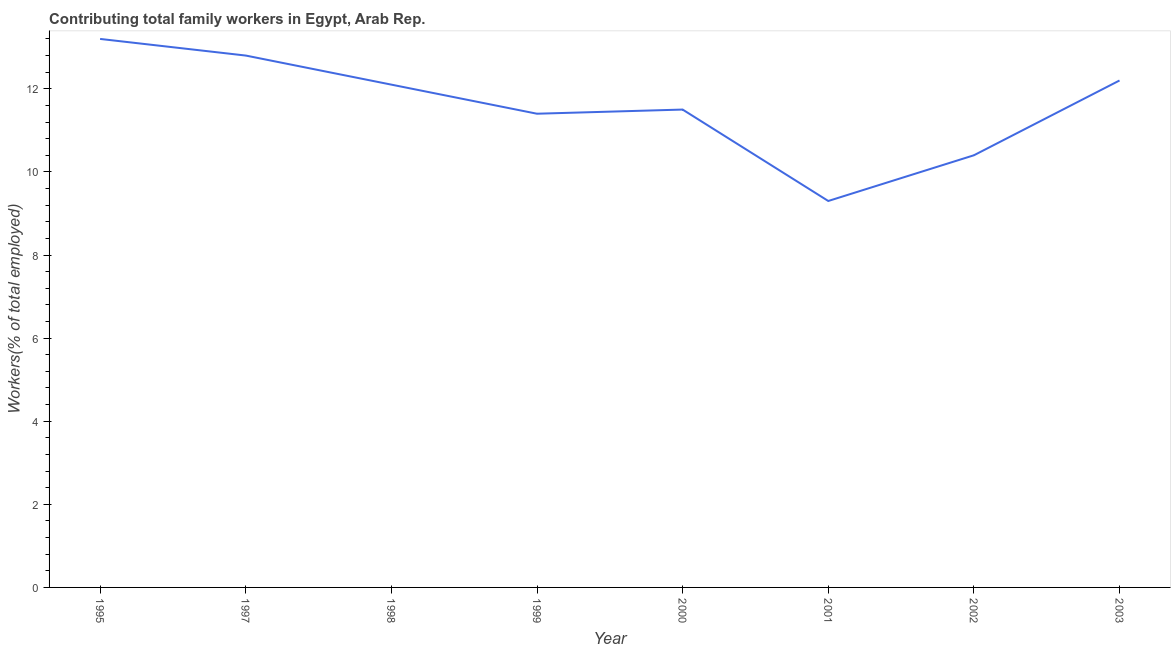What is the contributing family workers in 2002?
Provide a short and direct response. 10.4. Across all years, what is the maximum contributing family workers?
Provide a short and direct response. 13.2. Across all years, what is the minimum contributing family workers?
Your answer should be compact. 9.3. In which year was the contributing family workers minimum?
Provide a succinct answer. 2001. What is the sum of the contributing family workers?
Your response must be concise. 92.9. What is the difference between the contributing family workers in 2001 and 2002?
Keep it short and to the point. -1.1. What is the average contributing family workers per year?
Offer a very short reply. 11.61. What is the median contributing family workers?
Offer a terse response. 11.8. In how many years, is the contributing family workers greater than 11.2 %?
Make the answer very short. 6. Do a majority of the years between 1998 and 2000 (inclusive) have contributing family workers greater than 6.4 %?
Give a very brief answer. Yes. What is the ratio of the contributing family workers in 1995 to that in 2001?
Give a very brief answer. 1.42. Is the difference between the contributing family workers in 1999 and 2002 greater than the difference between any two years?
Offer a terse response. No. What is the difference between the highest and the second highest contributing family workers?
Ensure brevity in your answer.  0.4. What is the difference between the highest and the lowest contributing family workers?
Provide a short and direct response. 3.9. In how many years, is the contributing family workers greater than the average contributing family workers taken over all years?
Offer a terse response. 4. How many years are there in the graph?
Keep it short and to the point. 8. What is the difference between two consecutive major ticks on the Y-axis?
Make the answer very short. 2. Are the values on the major ticks of Y-axis written in scientific E-notation?
Your answer should be very brief. No. What is the title of the graph?
Your response must be concise. Contributing total family workers in Egypt, Arab Rep. What is the label or title of the X-axis?
Your response must be concise. Year. What is the label or title of the Y-axis?
Your response must be concise. Workers(% of total employed). What is the Workers(% of total employed) in 1995?
Ensure brevity in your answer.  13.2. What is the Workers(% of total employed) in 1997?
Keep it short and to the point. 12.8. What is the Workers(% of total employed) of 1998?
Make the answer very short. 12.1. What is the Workers(% of total employed) in 1999?
Give a very brief answer. 11.4. What is the Workers(% of total employed) in 2000?
Ensure brevity in your answer.  11.5. What is the Workers(% of total employed) in 2001?
Give a very brief answer. 9.3. What is the Workers(% of total employed) of 2002?
Your answer should be compact. 10.4. What is the Workers(% of total employed) in 2003?
Offer a very short reply. 12.2. What is the difference between the Workers(% of total employed) in 1995 and 1997?
Your response must be concise. 0.4. What is the difference between the Workers(% of total employed) in 1995 and 2001?
Ensure brevity in your answer.  3.9. What is the difference between the Workers(% of total employed) in 1997 and 1998?
Provide a succinct answer. 0.7. What is the difference between the Workers(% of total employed) in 1997 and 2000?
Your answer should be compact. 1.3. What is the difference between the Workers(% of total employed) in 1997 and 2001?
Offer a terse response. 3.5. What is the difference between the Workers(% of total employed) in 1997 and 2003?
Provide a succinct answer. 0.6. What is the difference between the Workers(% of total employed) in 1998 and 1999?
Your response must be concise. 0.7. What is the difference between the Workers(% of total employed) in 1998 and 2001?
Your answer should be compact. 2.8. What is the difference between the Workers(% of total employed) in 1998 and 2002?
Your response must be concise. 1.7. What is the difference between the Workers(% of total employed) in 1998 and 2003?
Offer a very short reply. -0.1. What is the difference between the Workers(% of total employed) in 1999 and 2001?
Offer a very short reply. 2.1. What is the difference between the Workers(% of total employed) in 1999 and 2002?
Give a very brief answer. 1. What is the difference between the Workers(% of total employed) in 2000 and 2002?
Your answer should be very brief. 1.1. What is the difference between the Workers(% of total employed) in 2001 and 2003?
Your answer should be compact. -2.9. What is the difference between the Workers(% of total employed) in 2002 and 2003?
Ensure brevity in your answer.  -1.8. What is the ratio of the Workers(% of total employed) in 1995 to that in 1997?
Your answer should be compact. 1.03. What is the ratio of the Workers(% of total employed) in 1995 to that in 1998?
Your response must be concise. 1.09. What is the ratio of the Workers(% of total employed) in 1995 to that in 1999?
Give a very brief answer. 1.16. What is the ratio of the Workers(% of total employed) in 1995 to that in 2000?
Your answer should be compact. 1.15. What is the ratio of the Workers(% of total employed) in 1995 to that in 2001?
Your answer should be very brief. 1.42. What is the ratio of the Workers(% of total employed) in 1995 to that in 2002?
Provide a succinct answer. 1.27. What is the ratio of the Workers(% of total employed) in 1995 to that in 2003?
Offer a very short reply. 1.08. What is the ratio of the Workers(% of total employed) in 1997 to that in 1998?
Ensure brevity in your answer.  1.06. What is the ratio of the Workers(% of total employed) in 1997 to that in 1999?
Your answer should be very brief. 1.12. What is the ratio of the Workers(% of total employed) in 1997 to that in 2000?
Provide a succinct answer. 1.11. What is the ratio of the Workers(% of total employed) in 1997 to that in 2001?
Offer a very short reply. 1.38. What is the ratio of the Workers(% of total employed) in 1997 to that in 2002?
Your answer should be compact. 1.23. What is the ratio of the Workers(% of total employed) in 1997 to that in 2003?
Offer a very short reply. 1.05. What is the ratio of the Workers(% of total employed) in 1998 to that in 1999?
Provide a short and direct response. 1.06. What is the ratio of the Workers(% of total employed) in 1998 to that in 2000?
Provide a succinct answer. 1.05. What is the ratio of the Workers(% of total employed) in 1998 to that in 2001?
Offer a terse response. 1.3. What is the ratio of the Workers(% of total employed) in 1998 to that in 2002?
Your answer should be compact. 1.16. What is the ratio of the Workers(% of total employed) in 1999 to that in 2000?
Your answer should be compact. 0.99. What is the ratio of the Workers(% of total employed) in 1999 to that in 2001?
Your answer should be very brief. 1.23. What is the ratio of the Workers(% of total employed) in 1999 to that in 2002?
Your answer should be very brief. 1.1. What is the ratio of the Workers(% of total employed) in 1999 to that in 2003?
Keep it short and to the point. 0.93. What is the ratio of the Workers(% of total employed) in 2000 to that in 2001?
Your answer should be compact. 1.24. What is the ratio of the Workers(% of total employed) in 2000 to that in 2002?
Your answer should be compact. 1.11. What is the ratio of the Workers(% of total employed) in 2000 to that in 2003?
Give a very brief answer. 0.94. What is the ratio of the Workers(% of total employed) in 2001 to that in 2002?
Your answer should be very brief. 0.89. What is the ratio of the Workers(% of total employed) in 2001 to that in 2003?
Offer a terse response. 0.76. What is the ratio of the Workers(% of total employed) in 2002 to that in 2003?
Your response must be concise. 0.85. 